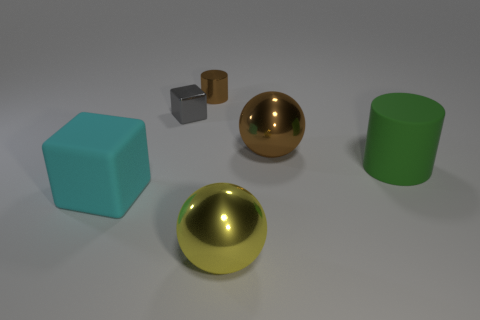Subtract 2 balls. How many balls are left? 0 Add 2 small purple cylinders. How many objects exist? 8 Subtract all green spheres. How many red cylinders are left? 0 Subtract all yellow shiny spheres. Subtract all big blocks. How many objects are left? 4 Add 5 big things. How many big things are left? 9 Add 1 big cyan metal cubes. How many big cyan metal cubes exist? 1 Subtract all brown cylinders. How many cylinders are left? 1 Subtract 0 red cylinders. How many objects are left? 6 Subtract all spheres. How many objects are left? 4 Subtract all cyan cylinders. Subtract all cyan spheres. How many cylinders are left? 2 